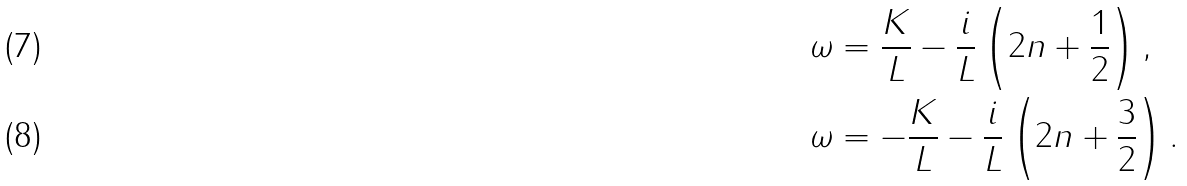<formula> <loc_0><loc_0><loc_500><loc_500>\omega & = \frac { K } { L } - \frac { i } { L } \left ( 2 n + \frac { 1 } { 2 } \right ) , \\ \omega & = - \frac { K } { L } - \frac { i } { L } \left ( 2 n + \frac { 3 } { 2 } \right ) .</formula> 